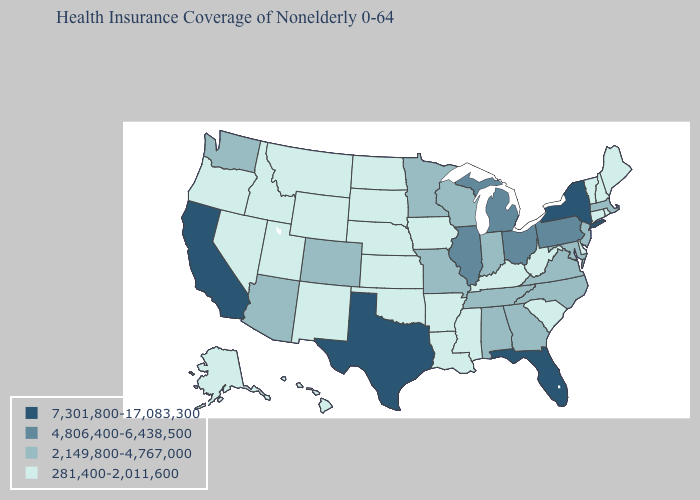Which states hav the highest value in the Northeast?
Quick response, please. New York. Name the states that have a value in the range 281,400-2,011,600?
Keep it brief. Alaska, Arkansas, Connecticut, Delaware, Hawaii, Idaho, Iowa, Kansas, Kentucky, Louisiana, Maine, Mississippi, Montana, Nebraska, Nevada, New Hampshire, New Mexico, North Dakota, Oklahoma, Oregon, Rhode Island, South Carolina, South Dakota, Utah, Vermont, West Virginia, Wyoming. What is the lowest value in the USA?
Quick response, please. 281,400-2,011,600. Does Texas have the highest value in the USA?
Be succinct. Yes. What is the value of Iowa?
Short answer required. 281,400-2,011,600. Name the states that have a value in the range 2,149,800-4,767,000?
Answer briefly. Alabama, Arizona, Colorado, Georgia, Indiana, Maryland, Massachusetts, Minnesota, Missouri, New Jersey, North Carolina, Tennessee, Virginia, Washington, Wisconsin. What is the value of Idaho?
Concise answer only. 281,400-2,011,600. What is the highest value in the West ?
Answer briefly. 7,301,800-17,083,300. Which states have the highest value in the USA?
Quick response, please. California, Florida, New York, Texas. Name the states that have a value in the range 2,149,800-4,767,000?
Keep it brief. Alabama, Arizona, Colorado, Georgia, Indiana, Maryland, Massachusetts, Minnesota, Missouri, New Jersey, North Carolina, Tennessee, Virginia, Washington, Wisconsin. Which states hav the highest value in the MidWest?
Write a very short answer. Illinois, Michigan, Ohio. What is the lowest value in the USA?
Give a very brief answer. 281,400-2,011,600. Name the states that have a value in the range 7,301,800-17,083,300?
Answer briefly. California, Florida, New York, Texas. Among the states that border Minnesota , which have the lowest value?
Concise answer only. Iowa, North Dakota, South Dakota. 